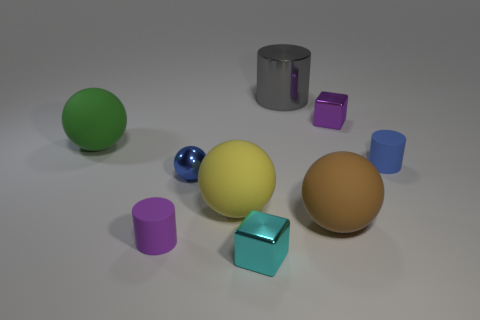What is the material of the blue object in front of the tiny rubber cylinder that is on the right side of the tiny metal thing that is left of the small cyan metallic object?
Give a very brief answer. Metal. What is the material of the sphere that is right of the big shiny thing on the right side of the yellow rubber ball?
Your response must be concise. Rubber. Is there anything else that is the same size as the yellow sphere?
Give a very brief answer. Yes. Does the big cylinder have the same material as the tiny cube that is in front of the tiny purple block?
Provide a short and direct response. Yes. There is a thing that is both behind the large green object and in front of the gray thing; what material is it?
Provide a short and direct response. Metal. There is a small metal object that is behind the small rubber cylinder on the right side of the blue metallic object; what is its color?
Your response must be concise. Purple. What is the material of the small cylinder behind the big brown rubber thing?
Offer a very short reply. Rubber. Is the number of big spheres less than the number of tiny blue things?
Offer a terse response. No. There is a blue metallic object; is it the same shape as the large brown thing to the right of the tiny cyan shiny thing?
Offer a very short reply. Yes. The large thing that is behind the large yellow rubber object and in front of the large cylinder has what shape?
Ensure brevity in your answer.  Sphere. 